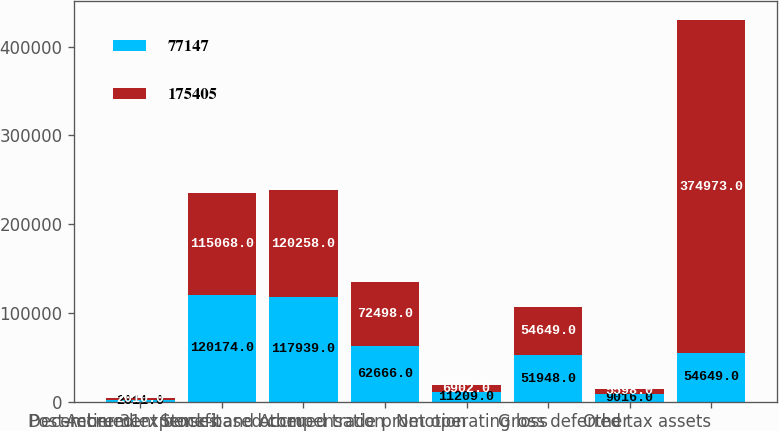<chart> <loc_0><loc_0><loc_500><loc_500><stacked_bar_chart><ecel><fcel>December 31<fcel>Post-retirement benefit<fcel>Accrued expenses and other<fcel>Stock-based compensation<fcel>Accrued trade promotion<fcel>Net operating loss<fcel>Other<fcel>Gross deferred tax assets<nl><fcel>77147<fcel>2011<fcel>120174<fcel>117939<fcel>62666<fcel>11209<fcel>51948<fcel>9016<fcel>54649<nl><fcel>175405<fcel>2010<fcel>115068<fcel>120258<fcel>72498<fcel>6902<fcel>54649<fcel>5598<fcel>374973<nl></chart> 